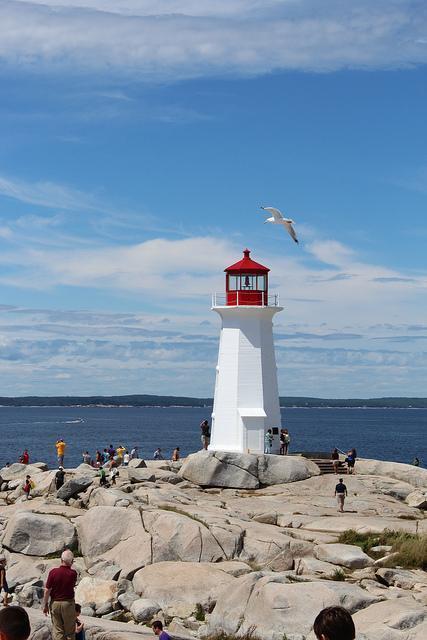How many birds are in the sky?
Give a very brief answer. 1. How many people are in the photo?
Give a very brief answer. 2. How many remote controls are in the photo?
Give a very brief answer. 0. 